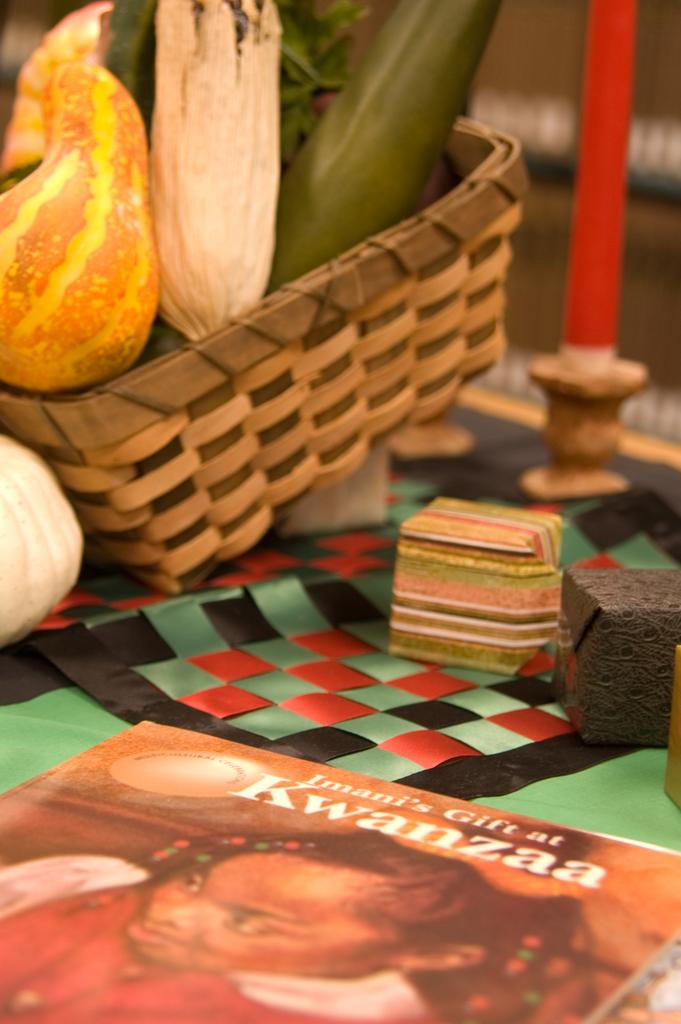What is located at the bottom of the image? There is a table at the bottom of the image. What is on the table? There is a book and a basket on the table. What is inside the basket? The basket contains vegetables. Is there anything else in the basket besides vegetables? Yes, there is a candle in the basket. What type of baseball is being used to process the vegetables in the image? There is no baseball present in the image, and vegetables are not being processed. 